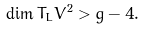<formula> <loc_0><loc_0><loc_500><loc_500>\dim T _ { L } V ^ { 2 } > g - 4 .</formula> 